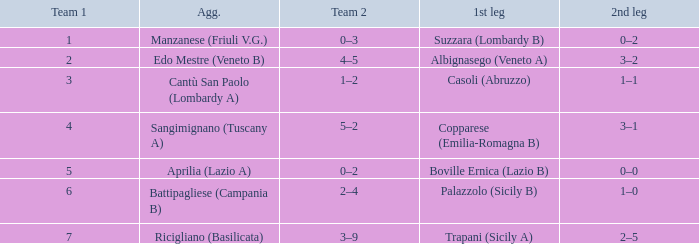What is the mean team 1 when the 1st leg is Albignasego (Veneto A)? 2.0. I'm looking to parse the entire table for insights. Could you assist me with that? {'header': ['Team 1', 'Agg.', 'Team 2', '1st leg', '2nd leg'], 'rows': [['1', 'Manzanese (Friuli V.G.)', '0–3', 'Suzzara (Lombardy B)', '0–2'], ['2', 'Edo Mestre (Veneto B)', '4–5', 'Albignasego (Veneto A)', '3–2'], ['3', 'Cantù San Paolo (Lombardy A)', '1–2', 'Casoli (Abruzzo)', '1–1'], ['4', 'Sangimignano (Tuscany A)', '5–2', 'Copparese (Emilia-Romagna B)', '3–1'], ['5', 'Aprilia (Lazio A)', '0–2', 'Boville Ernica (Lazio B)', '0–0'], ['6', 'Battipagliese (Campania B)', '2–4', 'Palazzolo (Sicily B)', '1–0'], ['7', 'Ricigliano (Basilicata)', '3–9', 'Trapani (Sicily A)', '2–5']]} 